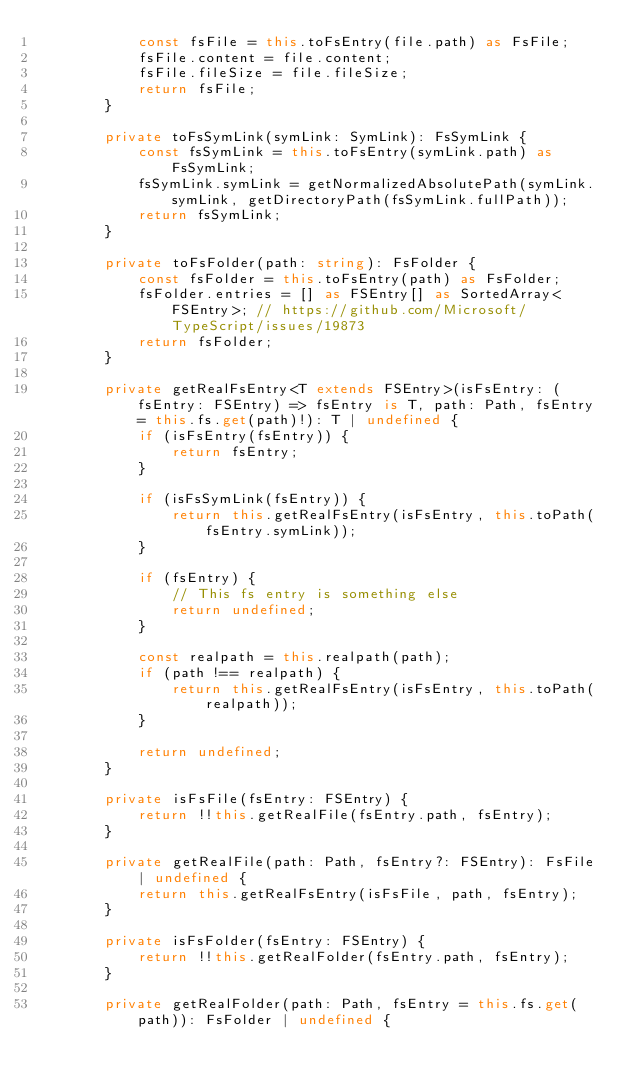<code> <loc_0><loc_0><loc_500><loc_500><_TypeScript_>            const fsFile = this.toFsEntry(file.path) as FsFile;
            fsFile.content = file.content;
            fsFile.fileSize = file.fileSize;
            return fsFile;
        }

        private toFsSymLink(symLink: SymLink): FsSymLink {
            const fsSymLink = this.toFsEntry(symLink.path) as FsSymLink;
            fsSymLink.symLink = getNormalizedAbsolutePath(symLink.symLink, getDirectoryPath(fsSymLink.fullPath));
            return fsSymLink;
        }

        private toFsFolder(path: string): FsFolder {
            const fsFolder = this.toFsEntry(path) as FsFolder;
            fsFolder.entries = [] as FSEntry[] as SortedArray<FSEntry>; // https://github.com/Microsoft/TypeScript/issues/19873
            return fsFolder;
        }

        private getRealFsEntry<T extends FSEntry>(isFsEntry: (fsEntry: FSEntry) => fsEntry is T, path: Path, fsEntry = this.fs.get(path)!): T | undefined {
            if (isFsEntry(fsEntry)) {
                return fsEntry;
            }

            if (isFsSymLink(fsEntry)) {
                return this.getRealFsEntry(isFsEntry, this.toPath(fsEntry.symLink));
            }

            if (fsEntry) {
                // This fs entry is something else
                return undefined;
            }

            const realpath = this.realpath(path);
            if (path !== realpath) {
                return this.getRealFsEntry(isFsEntry, this.toPath(realpath));
            }

            return undefined;
        }

        private isFsFile(fsEntry: FSEntry) {
            return !!this.getRealFile(fsEntry.path, fsEntry);
        }

        private getRealFile(path: Path, fsEntry?: FSEntry): FsFile | undefined {
            return this.getRealFsEntry(isFsFile, path, fsEntry);
        }

        private isFsFolder(fsEntry: FSEntry) {
            return !!this.getRealFolder(fsEntry.path, fsEntry);
        }

        private getRealFolder(path: Path, fsEntry = this.fs.get(path)): FsFolder | undefined {</code> 